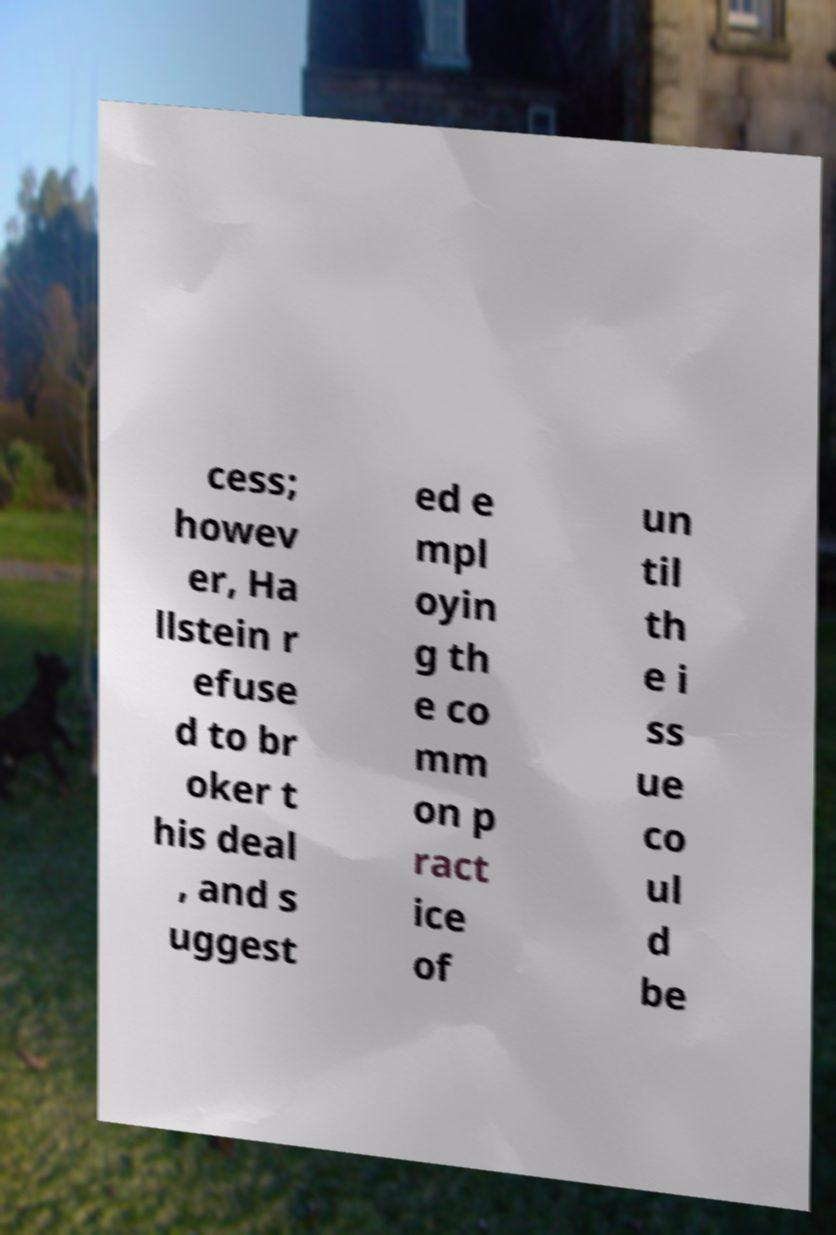Please identify and transcribe the text found in this image. cess; howev er, Ha llstein r efuse d to br oker t his deal , and s uggest ed e mpl oyin g th e co mm on p ract ice of un til th e i ss ue co ul d be 